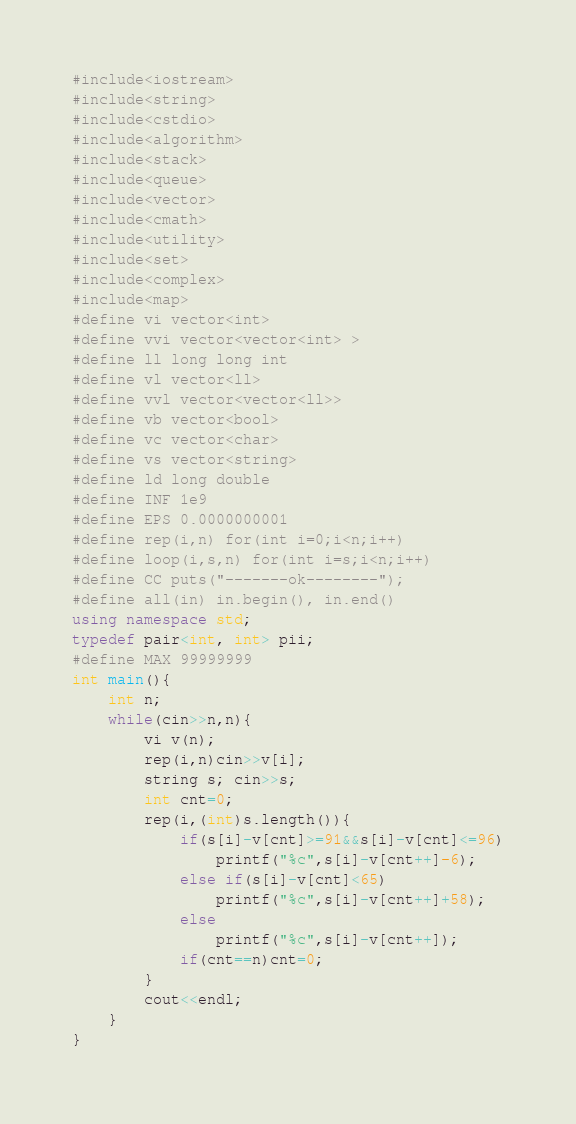<code> <loc_0><loc_0><loc_500><loc_500><_C++_>#include<iostream>
#include<string>
#include<cstdio>
#include<algorithm>
#include<stack>
#include<queue>
#include<vector>
#include<cmath>
#include<utility>
#include<set>
#include<complex>
#include<map>
#define vi vector<int>
#define vvi vector<vector<int> >
#define ll long long int
#define vl vector<ll>
#define vvl vector<vector<ll>>
#define vb vector<bool>
#define vc vector<char>
#define vs vector<string>
#define ld long double
#define INF 1e9
#define EPS 0.0000000001
#define rep(i,n) for(int i=0;i<n;i++)
#define loop(i,s,n) for(int i=s;i<n;i++)
#define CC puts("-------ok--------");
#define all(in) in.begin(), in.end()
using namespace std;
typedef pair<int, int> pii;
#define MAX 99999999
int main(){
    int n;
    while(cin>>n,n){
        vi v(n);
        rep(i,n)cin>>v[i];
        string s; cin>>s;
        int cnt=0;
        rep(i,(int)s.length()){
            if(s[i]-v[cnt]>=91&&s[i]-v[cnt]<=96)
                printf("%c",s[i]-v[cnt++]-6);
            else if(s[i]-v[cnt]<65)
                printf("%c",s[i]-v[cnt++]+58);
            else
                printf("%c",s[i]-v[cnt++]);
            if(cnt==n)cnt=0;
        }
        cout<<endl;
    }
}</code> 